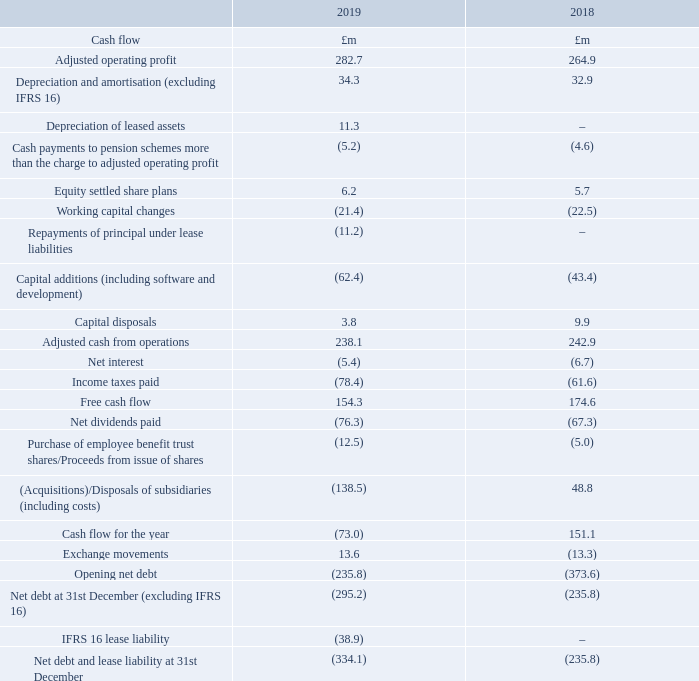Cash flow and treasury
Adjusted cash from operations is a measure of the cash flow generated from our companies over which the local management have control. A reconciliation between this and statutory operating cash flow can be found in Note 2 to the Financial Statements.
Adjusted cash from operations fell by £4.8 million to £238.1 million (2018: £242.9 million) representing 84% cash conversion. If we exclude the capital spend on the new Aflex facility this would rise to 90%.
Movements in working capital are discussed above.
Capital additions increased by £19.0 million. The most significant addition in the year was the £15.7 million spend on the construction of a new purpose-built factory in the UK for Aflex Hose, which will consolidate the existing four locations into a single facility, giving capacity for future growth while increasing efficiencies and providing a dedicated production line for Pharmaceutical products.
It is estimated that a further £6 million will be spent in 2020 in completing the project.
Looking forward, we would expect capital expenditure in 2020 to be at a similar level of approximately £65 million as we finish the Aflex facility but increase spending on project OPAL, the implementation of a global IT system for the Steam Specialties business. We generate significant cash and our first priority is to reinvest in the business, taking opportunities to generate good returns from increased efficiency, reduced costs and flexibility.
Tax paid in the year increased by £16.8 million to £78.4 million as tax rates rose and the Group grew. Free cash flow, defined in the table below, fell to £154.3 million (2018: £174.6 million) as a result of the increase in capital expenditure and tax.
Dividend payments were £76.3 million, including payments to minorities (2018: £67.3 million) and represent the final dividend for 2018 and the interim dividend for 2019.
There was a cash outflow, including fees, of £137.6 million on the acquisition of Thermocoax, as well as an additional £0.9 million outflow relating to the acquisition of various distribution rights. The net of share purchases and new shares issued for the Group’s various employee share schemes gave a cash outflow of £12.5 million (2018: £5.0 million) reflecting the move to acquire shares on the open market rather than issue new equity.
Due to the acquisition of Thermocoax, net debt increased from £235.8 million to £295.2 million at 31st December 2019, an expansion of £59.4 million. This equates to a net debt to EBITDA ratio of 0.9 times (2018: 0.8 times) excluding IFRS 16. EBITDA is defined in Note 2 and the components of net debt are disclosed in Note 24.
The Group’s Income Statement and Statement of Financial Position are exposed to movements in a wide range of different currencies.
This stems from our direct sales business model, with a large number of local operating units. These currency exposures and risks are managed through a rigorously applied Treasury Policy, typically using centrally managed and approved simple forward contracts to mitigate exposures to known cash flows and avoiding the use of complex derivative transactions. The largest exposures are to the euro, US dollar, Chinese renminbi and Korean won. Whilst currency effects can be significant, the structure of the Group provides some mitigation through our regional manufacturing presence, diverse spread of geographic locations and through the natural hedge of having a high proportion of our overhead costs in the local currencies of our direct sales operating units.
Capital structure
The Board keeps the capital requirements of the Group under regular review, maintaining a strong financial position to protect the business and provide flexibility of funding for growth. The Group earns a high return on capital, which is reflected in strong cash generation over time. Our capital allocation policy remains unchanged. Our first priority is to maximise investment in the business to generate further good returns in the future, aligned with our strategy for growth and targeting improvement in our key performance indicators. Next, we prioritise finding suitable acquisitions that can expand our addressable market through increasing our geographic reach, deepening our market penetration or broadening our product range. Acquisition targets need to exhibit a good strategic fit and meet strict commercial, economic and return on investment criteria. When cash resources significantly exceed expected future requirements, we would look to return capital to shareholders, as evidenced by special dividends declared in respect of 2010, 2012 and 2014. However, in the near term, we will look to reduce our financial leverage prior to considering new returns of capital to shareholders.
What is the amount of dividend payments in 2019? £76.3 million. What led to the increase in net debt in 2019? The acquisition of thermocoax. What was the  Net debt and lease liability at 31st December for 2018 and 2019 respectively?
Answer scale should be: million. (334.1), (235.8). In which year was the amount of Depreciation and amortisation (excluding IFRS 16) larger? 34.3>32.9
Answer: 2019. What was the change in free cash flow in 2019 from 2018?
Answer scale should be: million. 154.3-174.6
Answer: -20.3. What was the percentage change in free cash flow in 2019 from 2018?
Answer scale should be: percent. (154.3-174.6)/174.6
Answer: -11.63. 